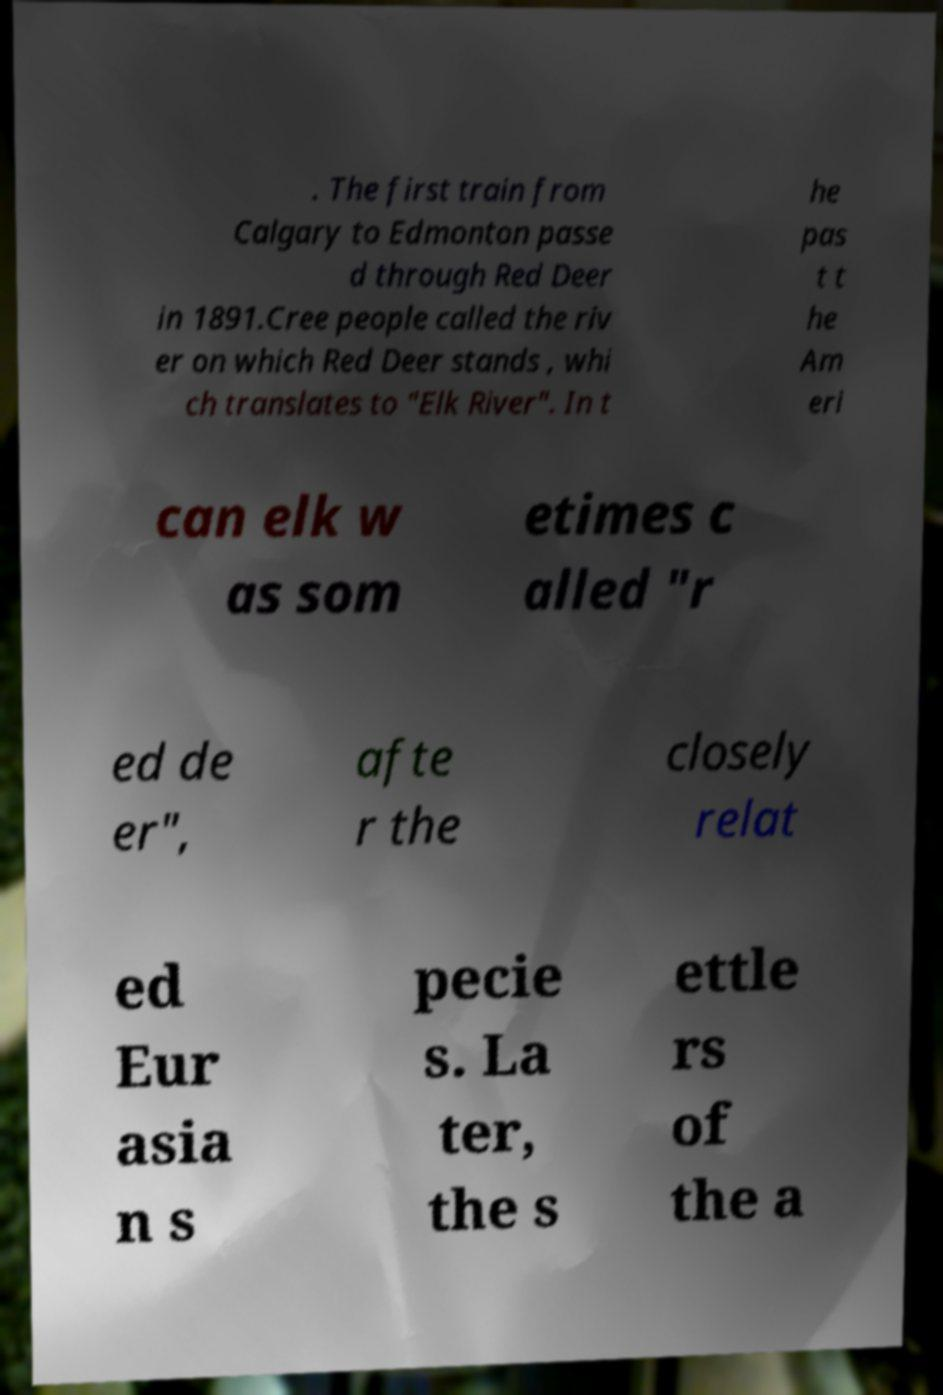There's text embedded in this image that I need extracted. Can you transcribe it verbatim? . The first train from Calgary to Edmonton passe d through Red Deer in 1891.Cree people called the riv er on which Red Deer stands , whi ch translates to "Elk River". In t he pas t t he Am eri can elk w as som etimes c alled "r ed de er", afte r the closely relat ed Eur asia n s pecie s. La ter, the s ettle rs of the a 